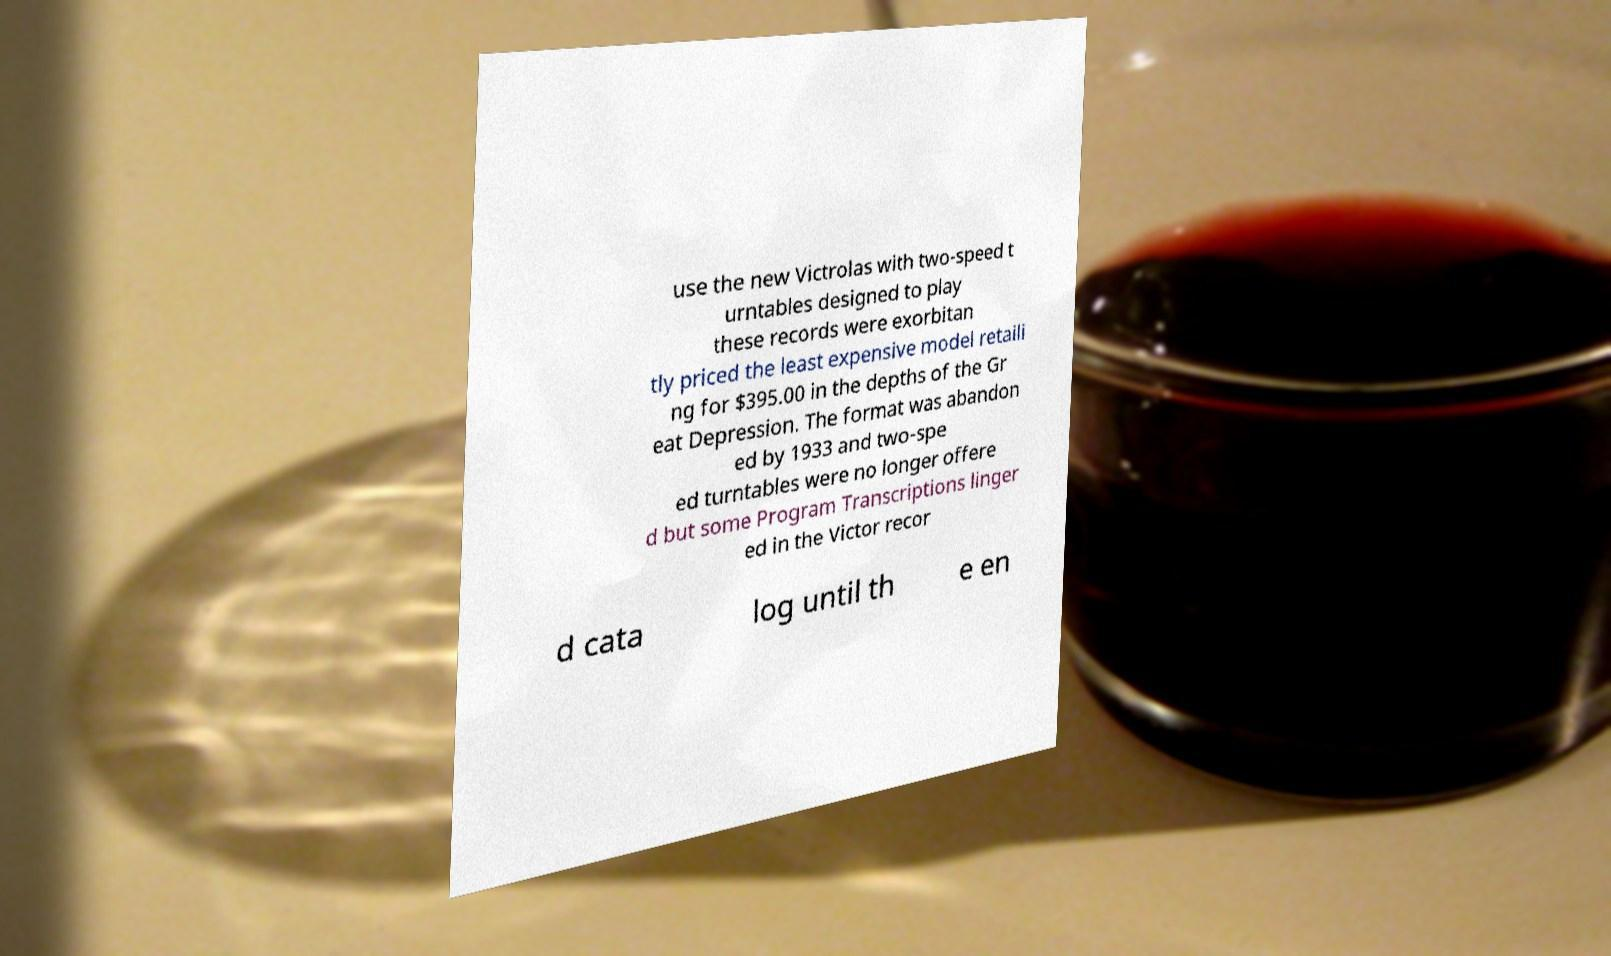What messages or text are displayed in this image? I need them in a readable, typed format. use the new Victrolas with two-speed t urntables designed to play these records were exorbitan tly priced the least expensive model retaili ng for $395.00 in the depths of the Gr eat Depression. The format was abandon ed by 1933 and two-spe ed turntables were no longer offere d but some Program Transcriptions linger ed in the Victor recor d cata log until th e en 